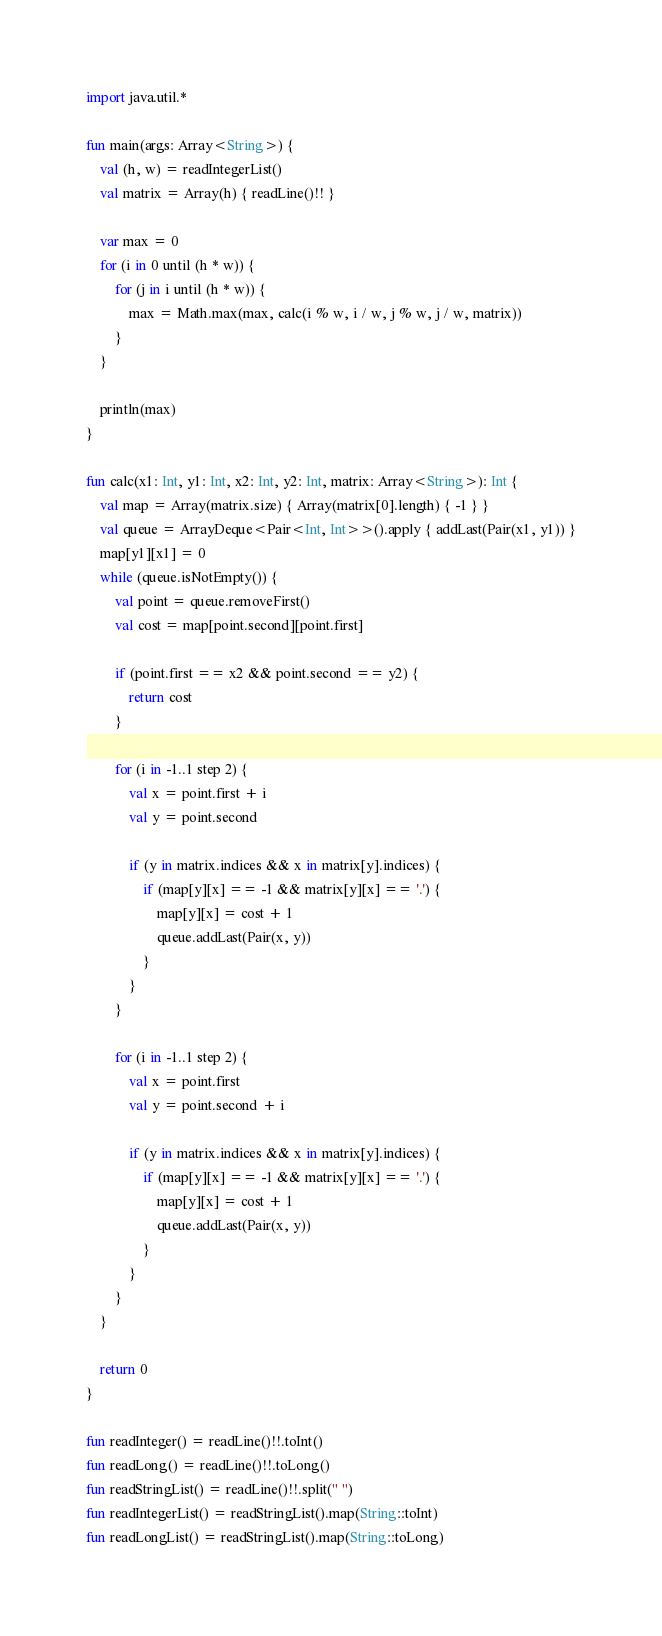<code> <loc_0><loc_0><loc_500><loc_500><_Kotlin_>import java.util.*

fun main(args: Array<String>) {
    val (h, w) = readIntegerList()
    val matrix = Array(h) { readLine()!! }

    var max = 0
    for (i in 0 until (h * w)) {
        for (j in i until (h * w)) {
            max = Math.max(max, calc(i % w, i / w, j % w, j / w, matrix))
        }
    }

    println(max)
}

fun calc(x1: Int, y1: Int, x2: Int, y2: Int, matrix: Array<String>): Int {
    val map = Array(matrix.size) { Array(matrix[0].length) { -1 } }
    val queue = ArrayDeque<Pair<Int, Int>>().apply { addLast(Pair(x1, y1)) }
    map[y1][x1] = 0
    while (queue.isNotEmpty()) {
        val point = queue.removeFirst()
        val cost = map[point.second][point.first]

        if (point.first == x2 && point.second == y2) {
            return cost
        }

        for (i in -1..1 step 2) {
            val x = point.first + i
            val y = point.second

            if (y in matrix.indices && x in matrix[y].indices) {
                if (map[y][x] == -1 && matrix[y][x] == '.') {
                    map[y][x] = cost + 1
                    queue.addLast(Pair(x, y))
                }
            }
        }

        for (i in -1..1 step 2) {
            val x = point.first
            val y = point.second + i

            if (y in matrix.indices && x in matrix[y].indices) {
                if (map[y][x] == -1 && matrix[y][x] == '.') {
                    map[y][x] = cost + 1
                    queue.addLast(Pair(x, y))
                }
            }
        }
    }

    return 0
}

fun readInteger() = readLine()!!.toInt()
fun readLong() = readLine()!!.toLong()
fun readStringList() = readLine()!!.split(" ")
fun readIntegerList() = readStringList().map(String::toInt)
fun readLongList() = readStringList().map(String::toLong)
</code> 